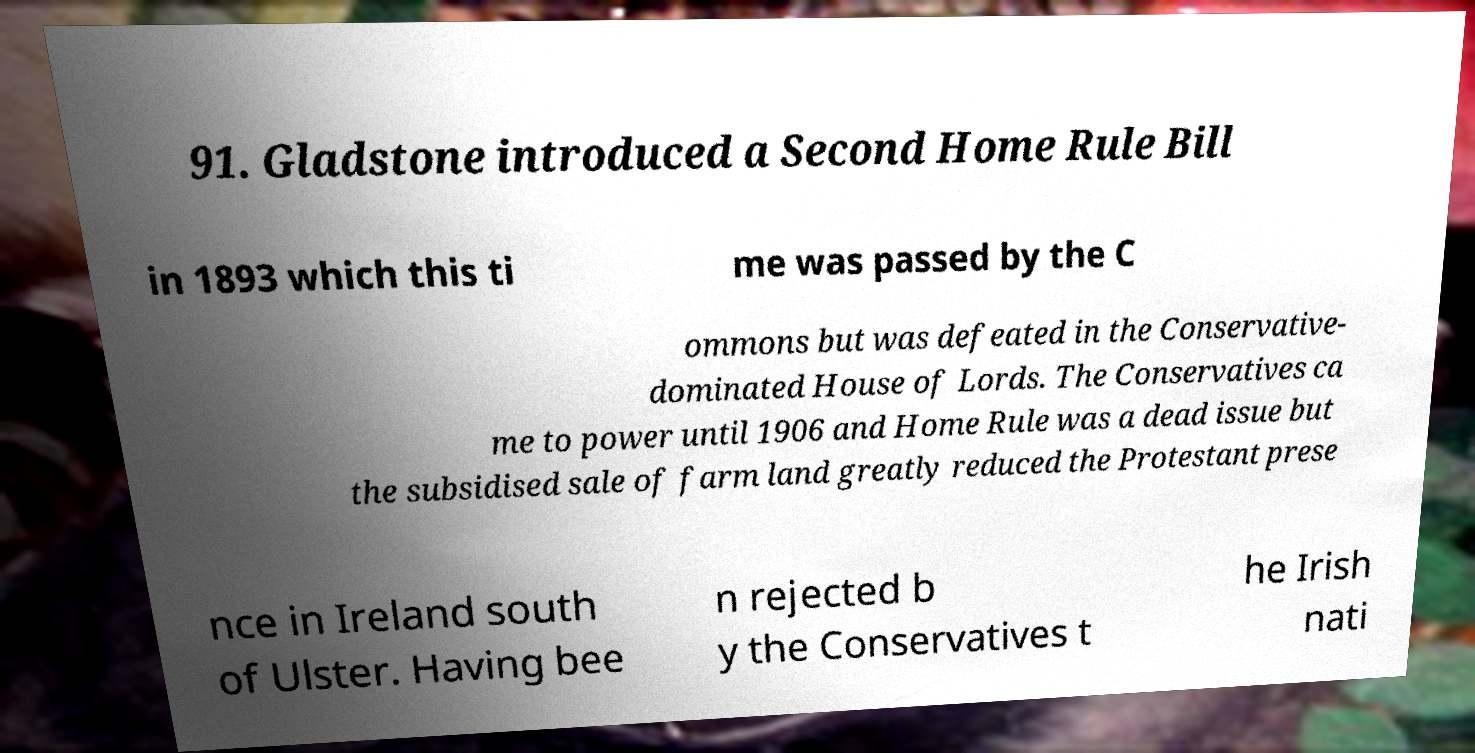Could you extract and type out the text from this image? 91. Gladstone introduced a Second Home Rule Bill in 1893 which this ti me was passed by the C ommons but was defeated in the Conservative- dominated House of Lords. The Conservatives ca me to power until 1906 and Home Rule was a dead issue but the subsidised sale of farm land greatly reduced the Protestant prese nce in Ireland south of Ulster. Having bee n rejected b y the Conservatives t he Irish nati 